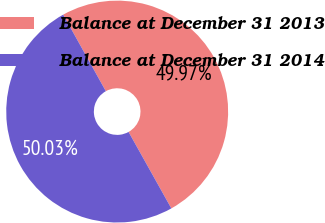<chart> <loc_0><loc_0><loc_500><loc_500><pie_chart><fcel>Balance at December 31 2013<fcel>Balance at December 31 2014<nl><fcel>49.97%<fcel>50.03%<nl></chart> 